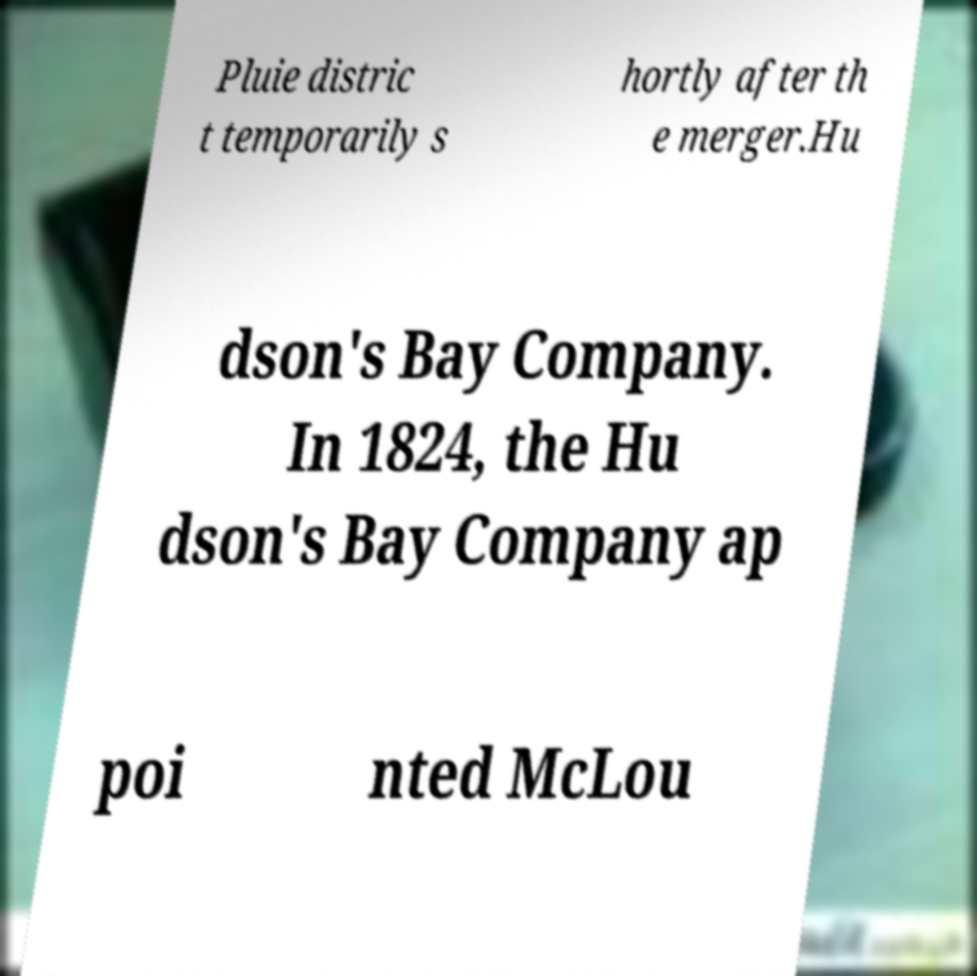Please identify and transcribe the text found in this image. Pluie distric t temporarily s hortly after th e merger.Hu dson's Bay Company. In 1824, the Hu dson's Bay Company ap poi nted McLou 